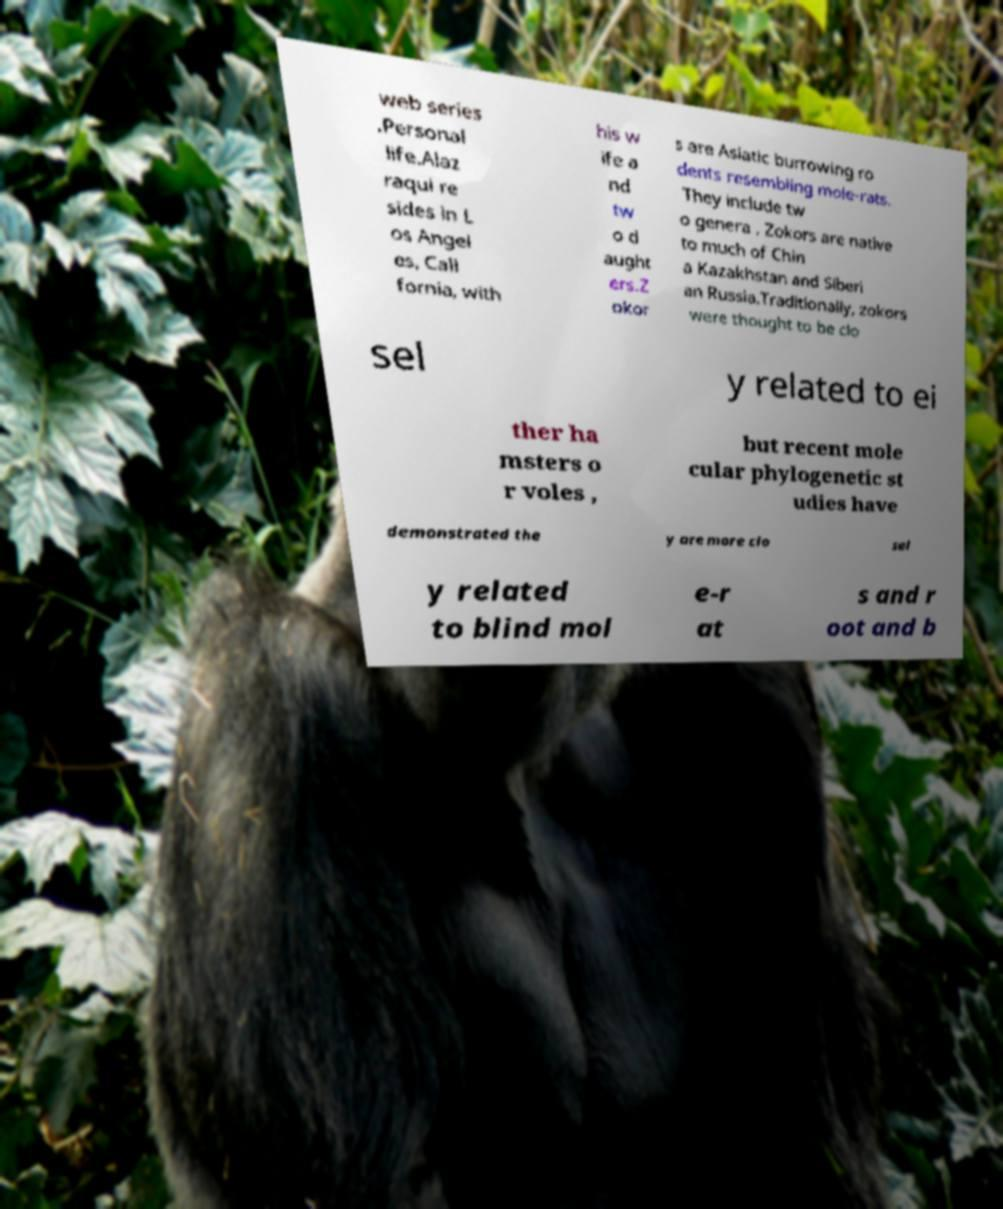Could you assist in decoding the text presented in this image and type it out clearly? web series .Personal life.Alaz raqui re sides in L os Angel es, Cali fornia, with his w ife a nd tw o d aught ers.Z okor s are Asiatic burrowing ro dents resembling mole-rats. They include tw o genera . Zokors are native to much of Chin a Kazakhstan and Siberi an Russia.Traditionally, zokors were thought to be clo sel y related to ei ther ha msters o r voles , but recent mole cular phylogenetic st udies have demonstrated the y are more clo sel y related to blind mol e-r at s and r oot and b 